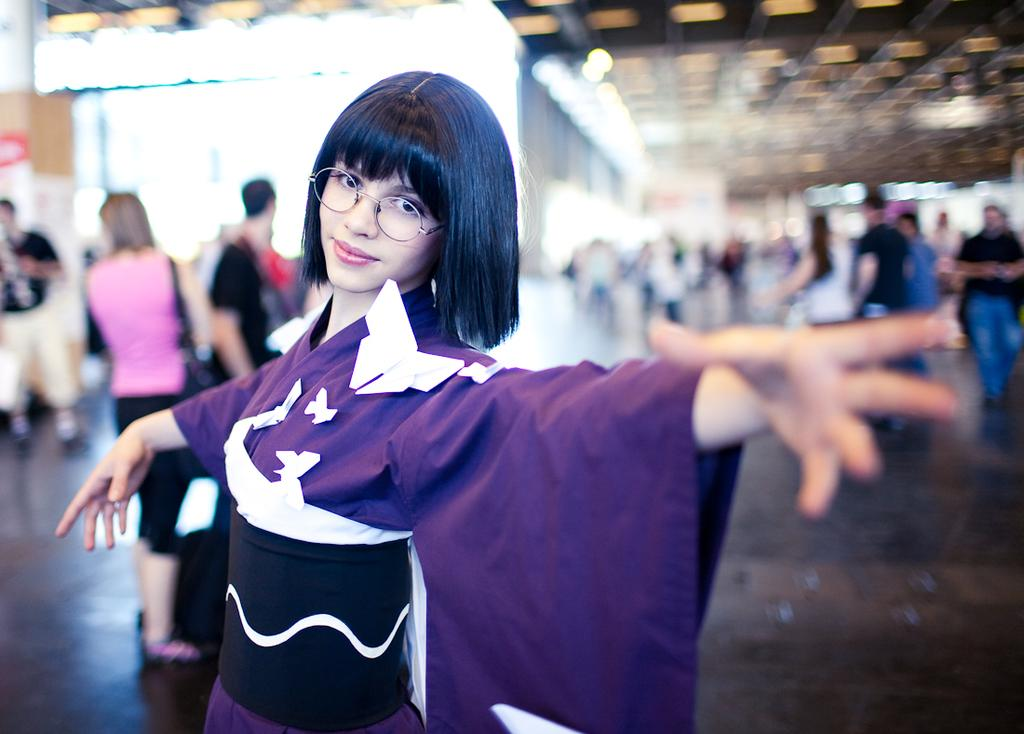What is the main subject of the image? There is a woman standing in the image. Can you describe the woman's appearance? The woman is wearing clothes and spectacles. Are there any other people in the image? Yes, there are other people standing in the image, and some people are walking. What can be observed about the background of the image? The background is blurred. Can you tell me how many times the woman folds her mask in the image? There is no mask present in the image, so the woman cannot fold it. What type of request is being made by the people walking in the image? There is no indication of a request being made in the image; people are simply walking. 